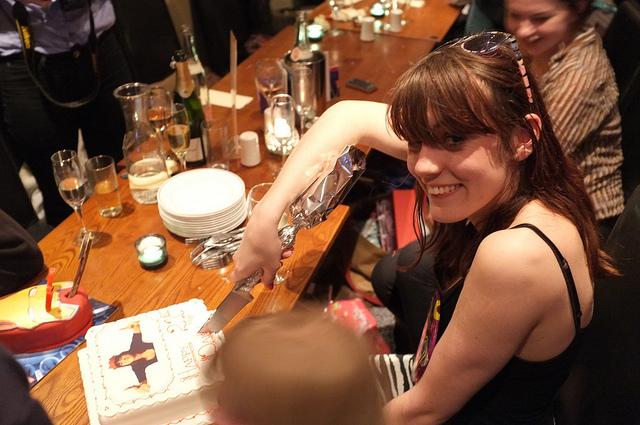Is she holding a knife?
Give a very brief answer. Yes. Where is the cake?
Answer briefly. Table. Are the glasses full?
Concise answer only. No. 